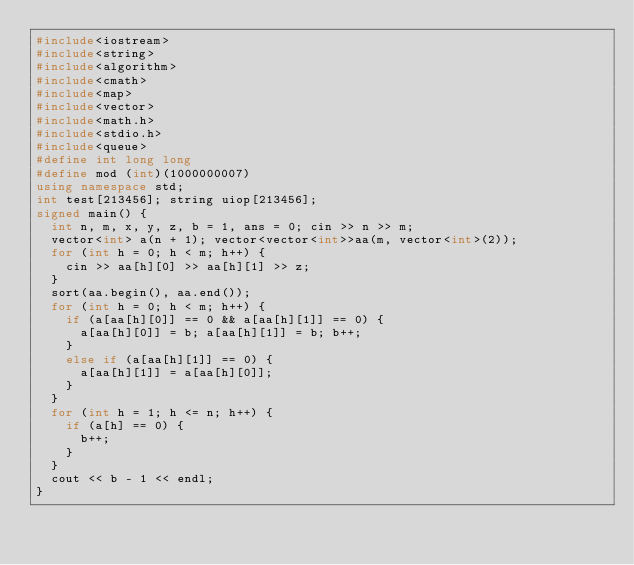Convert code to text. <code><loc_0><loc_0><loc_500><loc_500><_C++_>#include<iostream>
#include<string>
#include<algorithm>    
#include<cmath>
#include<map>
#include<vector>
#include<math.h>
#include<stdio.h>
#include<queue>
#define int long long
#define mod (int)(1000000007)
using namespace std;
int test[213456]; string uiop[213456];
signed main() {
	int n, m, x, y, z, b = 1, ans = 0; cin >> n >> m;
	vector<int> a(n + 1); vector<vector<int>>aa(m, vector<int>(2));
	for (int h = 0; h < m; h++) {
		cin >> aa[h][0] >> aa[h][1] >> z;
	}
	sort(aa.begin(), aa.end());
	for (int h = 0; h < m; h++) {
		if (a[aa[h][0]] == 0 && a[aa[h][1]] == 0) {
			a[aa[h][0]] = b; a[aa[h][1]] = b; b++;
		}
		else if (a[aa[h][1]] == 0) {
			a[aa[h][1]] = a[aa[h][0]];
		}
	}
	for (int h = 1; h <= n; h++) {
		if (a[h] == 0) {
			b++;
		}
	}
	cout << b - 1 << endl;
}</code> 